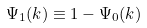<formula> <loc_0><loc_0><loc_500><loc_500>\Psi _ { 1 } ( k ) \equiv 1 - \Psi _ { 0 } ( k ) \</formula> 